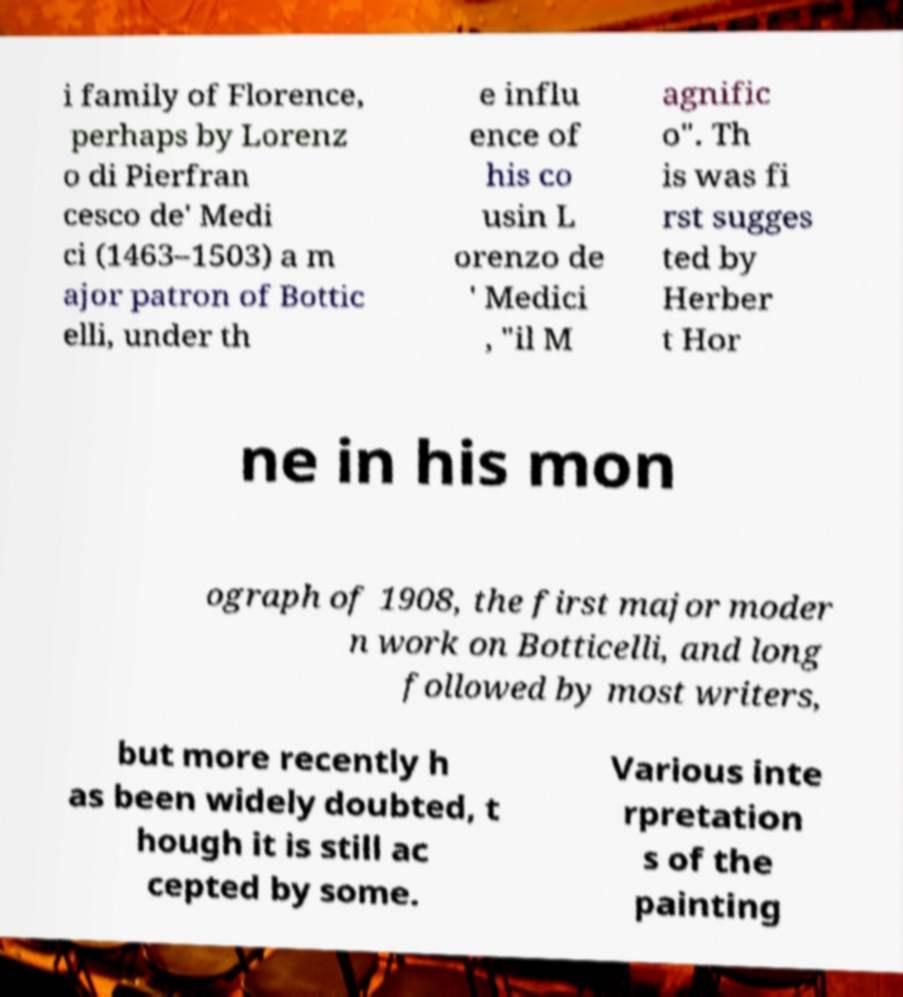Could you extract and type out the text from this image? i family of Florence, perhaps by Lorenz o di Pierfran cesco de' Medi ci (1463–1503) a m ajor patron of Bottic elli, under th e influ ence of his co usin L orenzo de ' Medici , "il M agnific o". Th is was fi rst sugges ted by Herber t Hor ne in his mon ograph of 1908, the first major moder n work on Botticelli, and long followed by most writers, but more recently h as been widely doubted, t hough it is still ac cepted by some. Various inte rpretation s of the painting 